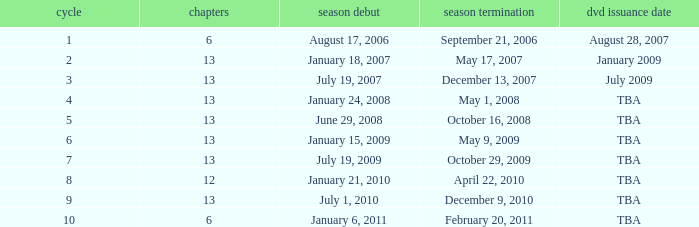On what date was the DVD released for the season with fewer than 13 episodes that aired before season 8? August 28, 2007. 